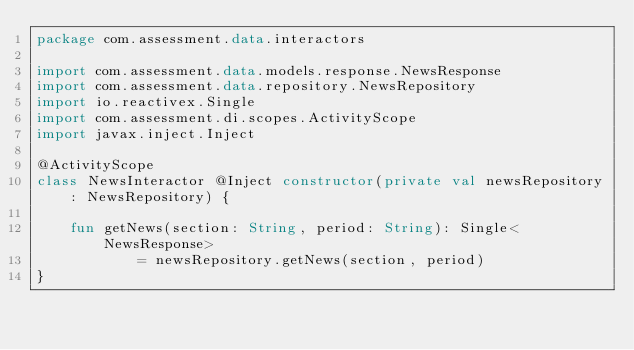<code> <loc_0><loc_0><loc_500><loc_500><_Kotlin_>package com.assessment.data.interactors

import com.assessment.data.models.response.NewsResponse
import com.assessment.data.repository.NewsRepository
import io.reactivex.Single
import com.assessment.di.scopes.ActivityScope
import javax.inject.Inject

@ActivityScope
class NewsInteractor @Inject constructor(private val newsRepository: NewsRepository) {

    fun getNews(section: String, period: String): Single<NewsResponse>
            = newsRepository.getNews(section, period)
}</code> 